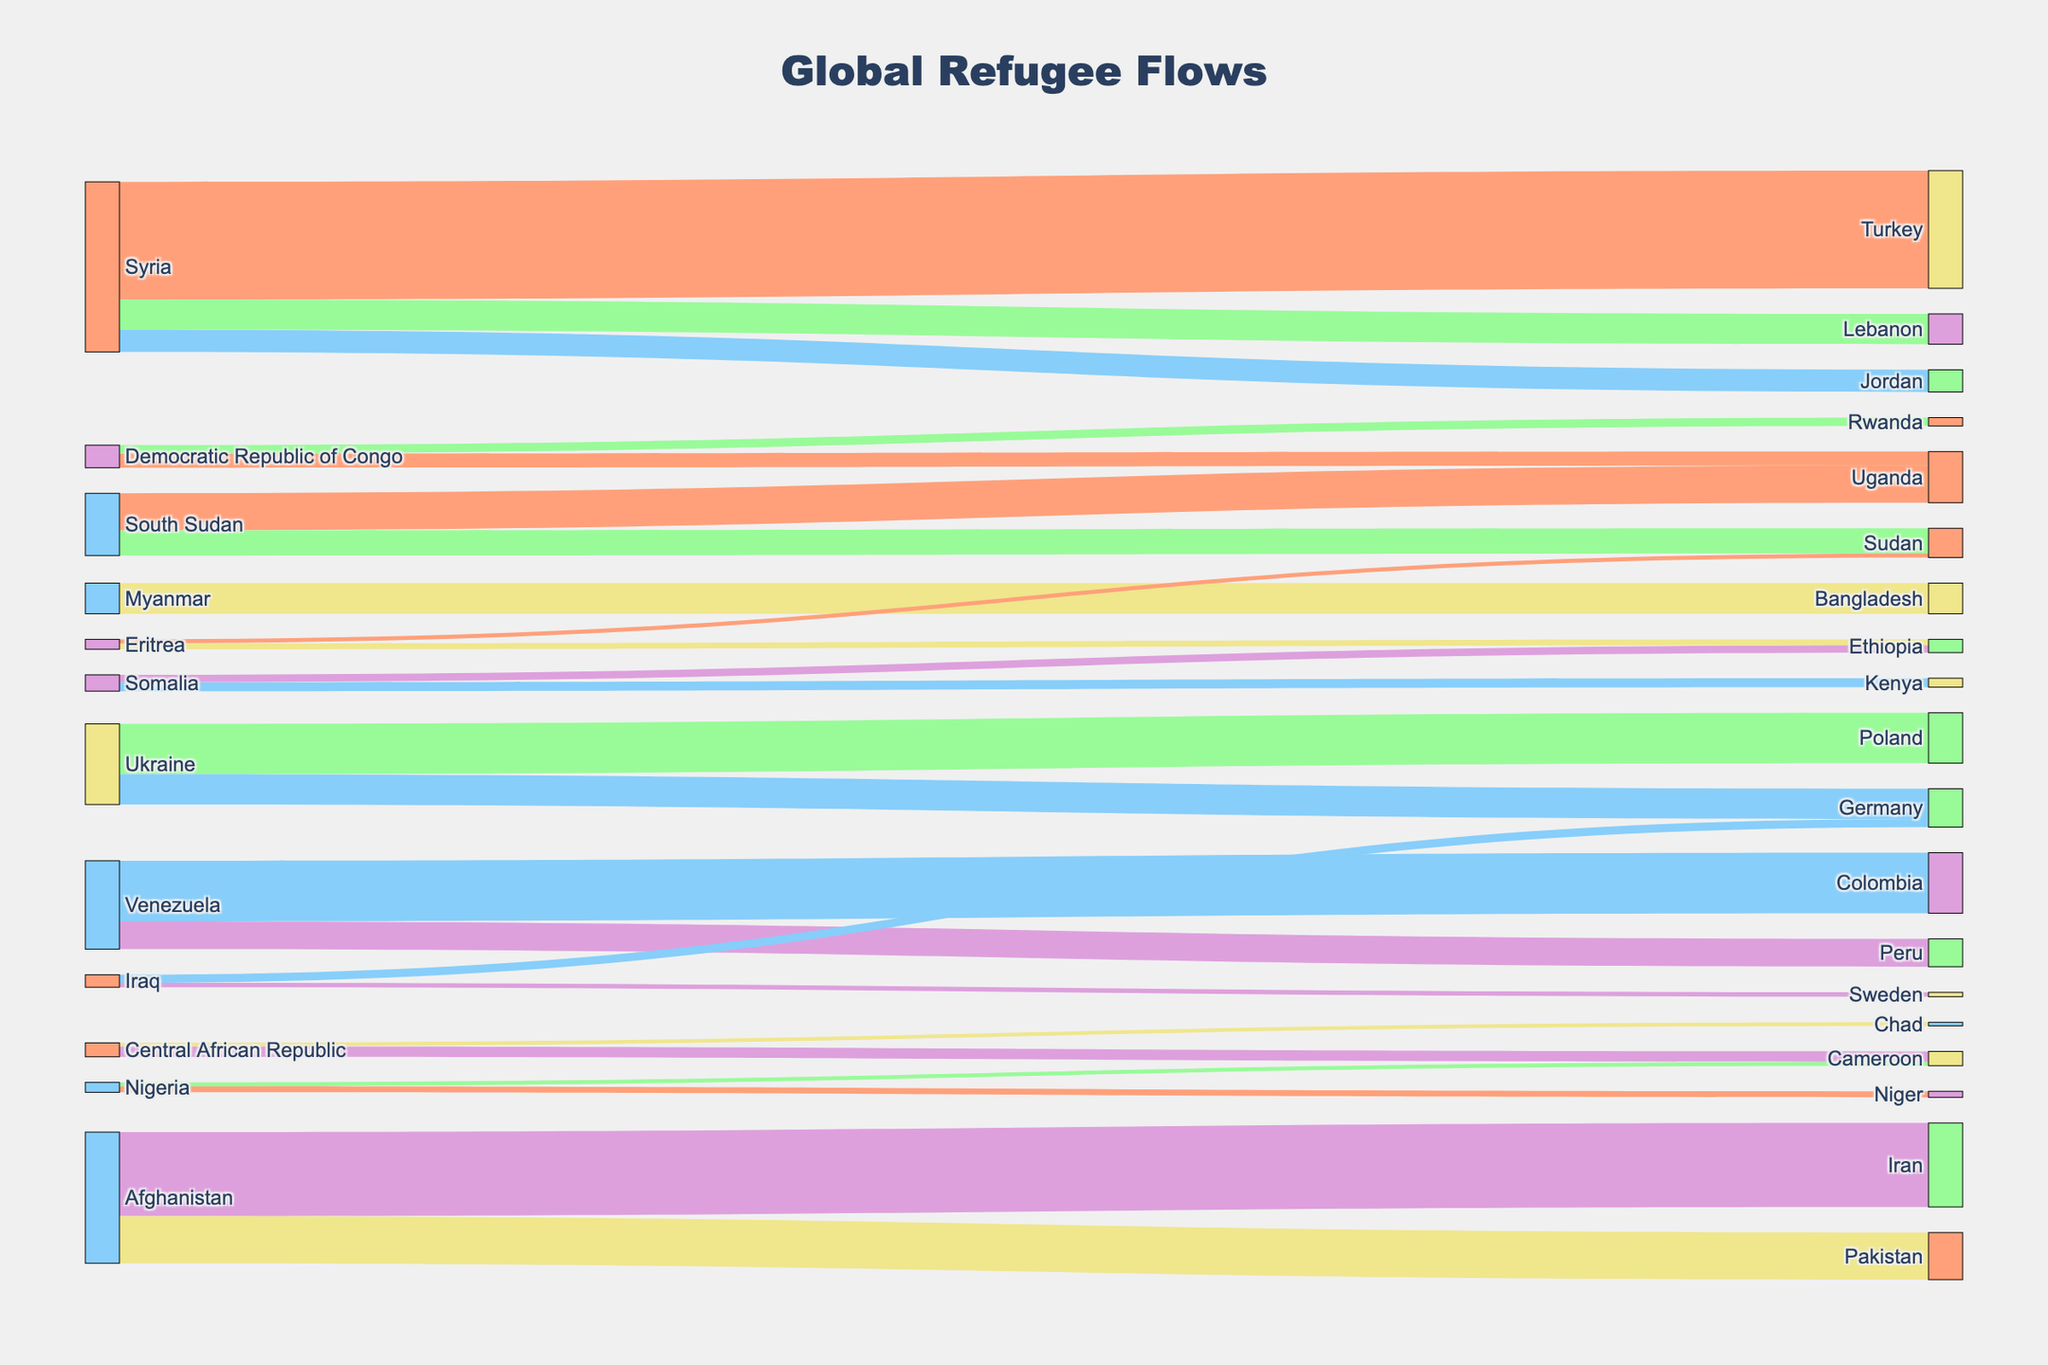What is the title of the figure? The title of the figure is prominently displayed at the top and helps identify the overall content being visualized. Observing the top part of the figure, it reads "Global Refugee Flows".
Answer: Global Refugee Flows Which country has the highest number of refugees going to Turkey? By examining the connections leading to Turkey and observing the width of the flows or values shown, we can see that the flow from Syria to Turkey is the largest.
Answer: Syria How many refugees have flown from the Democratic Republic of Congo to Uganda? To find this, trace the link from the Democratic Republic of Congo to Uganda and check the value associated with this link. The figure shows 420,000 refugees.
Answer: 420,000 Compare the number of refugees from Syria to Lebanon and Jordan. Which route has more refugees? Observe the connections from Syria to both Lebanon and Jordan. The values show that 900,000 refugees went to Lebanon and 660,000 to Jordan. By comparison, Lebanon has more refugees from Syria.
Answer: Lebanon What is the total number of refugees from South Sudan? To find the total number, sum the values of refugees going from South Sudan to Uganda and Sudan, which are 1,100,000 and 750,000 respectively. The total is 1,100,000 + 750,000 = 1,850,000 refugees.
Answer: 1,850,000 Which country has more refugees from Eritrea, Sudan or Ethiopia? Compare the values of the flows from Eritrea to both Sudan and Ethiopia. The values indicate that Sudan has 120,000 refugees and Ethiopia has 175,000 refugees from Eritrea. Ethiopia has more refugees.
Answer: Ethiopia How does the number of refugees from Venezuela to Colombia compare to the number from Venezuela to Peru? Examine the flows from Venezuela to both Colombia and Peru. The values show that 1,800,000 refugees went to Colombia and 830,000 to Peru, thus Colombia has significantly more refugees.
Answer: Colombia Which destination received the largest number of Ukrainian refugees? By examining the destinations for Ukrainian refugees, observe the values going to each country. The values show that Poland received 1,500,000 Ukrainian refugees which is the largest number compared to Germany.
Answer: Poland What is the combined number of refugees from Afghanistan to Iran and Pakistan? To find the combined number, sum the values of refugees going from Afghanistan to Iran and Pakistan. The values show 2,500,000 to Iran and 1,400,000 to Pakistan. The sum is 2,500,000 + 1,400,000 = 3,900,000 refugees.
Answer: 3,900,000 Which country in Europe received more refugees from Iraq, Germany or Sweden? Check the values of the flows from Iraq to both Germany and Sweden. The values show 240,000 Iraqi refugees in Germany and 130,000 in Sweden. Therefore, Germany received more refugees from Iraq.
Answer: Germany 